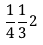<formula> <loc_0><loc_0><loc_500><loc_500>\frac { 1 } { 4 } \frac { 1 } { 3 } 2</formula> 